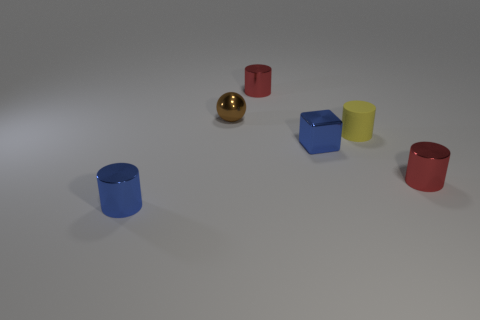Subtract all tiny metal cylinders. How many cylinders are left? 1 Add 3 tiny objects. How many objects exist? 9 Subtract all red cylinders. How many cylinders are left? 2 Subtract all balls. How many objects are left? 5 Subtract all yellow blocks. Subtract all brown balls. How many blocks are left? 1 Subtract all red balls. How many cyan cylinders are left? 0 Subtract all metallic blocks. Subtract all tiny brown blocks. How many objects are left? 5 Add 2 tiny rubber cylinders. How many tiny rubber cylinders are left? 3 Add 2 small red metallic objects. How many small red metallic objects exist? 4 Subtract 0 red balls. How many objects are left? 6 